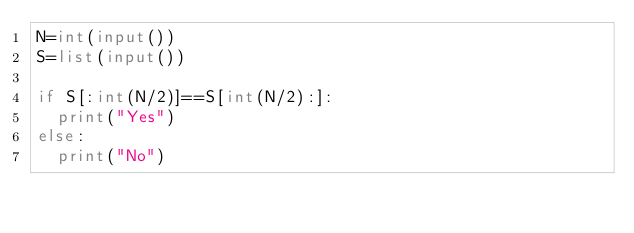Convert code to text. <code><loc_0><loc_0><loc_500><loc_500><_Python_>N=int(input())
S=list(input())

if S[:int(N/2)]==S[int(N/2):]:
  print("Yes")
else:
  print("No")</code> 